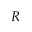<formula> <loc_0><loc_0><loc_500><loc_500>R</formula> 